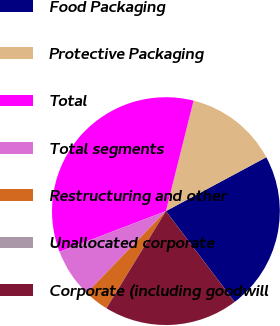Convert chart to OTSL. <chart><loc_0><loc_0><loc_500><loc_500><pie_chart><fcel>Food Packaging<fcel>Protective Packaging<fcel>Total<fcel>Total segments<fcel>Restructuring and other<fcel>Unallocated corporate<fcel>Corporate (including goodwill<nl><fcel>22.53%<fcel>13.26%<fcel>34.71%<fcel>6.95%<fcel>3.48%<fcel>0.01%<fcel>19.06%<nl></chart> 